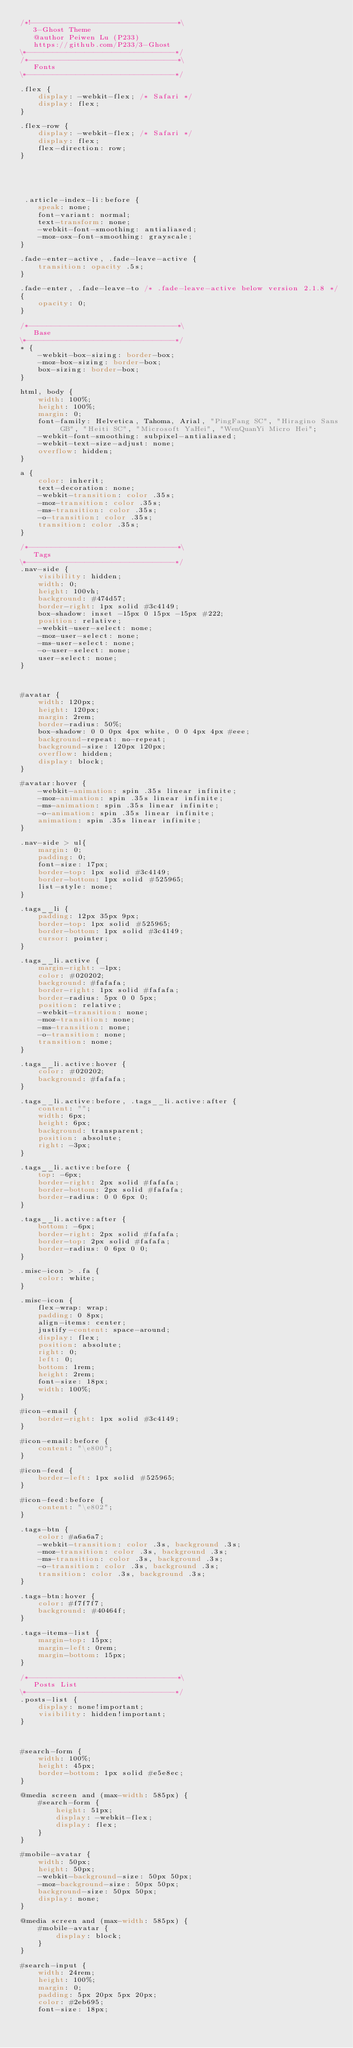Convert code to text. <code><loc_0><loc_0><loc_500><loc_500><_CSS_>/*!--------------------------------*\
   3-Ghost Theme
   @author Peiwen Lu (P233)
   https://github.com/P233/3-Ghost
\*---------------------------------*/
/*---------------------------------*\
   Fonts
\*---------------------------------*/

.flex {
    display: -webkit-flex; /* Safari */
    display: flex;
}

.flex-row {
    display: -webkit-flex; /* Safari */
    display: flex;
    flex-direction: row;
}





 .article-index-li:before {
    speak: none;
    font-variant: normal;
    text-transform: none;
    -webkit-font-smoothing: antialiased;
    -moz-osx-font-smoothing: grayscale;
}

.fade-enter-active, .fade-leave-active {
    transition: opacity .5s;
}

.fade-enter, .fade-leave-to /* .fade-leave-active below version 2.1.8 */
{
    opacity: 0;
}

/*---------------------------------*\
   Base
\*---------------------------------*/
* {
    -webkit-box-sizing: border-box;
    -moz-box-sizing: border-box;
    box-sizing: border-box;
}

html, body {
    width: 100%;
    height: 100%;
    margin: 0;
    font-family: Helvetica, Tahoma, Arial, "PingFang SC", "Hiragino Sans GB", "Heiti SC", "Microsoft YaHei", "WenQuanYi Micro Hei";
    -webkit-font-smoothing: subpixel-antialiased;
    -webkit-text-size-adjust: none;
    overflow: hidden;
}

a {
    color: inherit;
    text-decoration: none;
    -webkit-transition: color .35s;
    -moz-transition: color .35s;
    -ms-transition: color .35s;
    -o-transition: color .35s;
    transition: color .35s;
}

/*---------------------------------*\
   Tags
\*---------------------------------*/
.nav-side {
    visibility: hidden;
    width: 0;
    height: 100vh;
    background: #474d57;
    border-right: 1px solid #3c4149;
    box-shadow: inset -15px 0 15px -15px #222;
    position: relative;
    -webkit-user-select: none;
    -moz-user-select: none;
    -ms-user-select: none;
    -o-user-select: none;
    user-select: none;
}



#avatar {
    width: 120px;
    height: 120px;
    margin: 2rem;
    border-radius: 50%;
    box-shadow: 0 0 0px 4px white, 0 0 4px 4px #eee;
    background-repeat: no-repeat;
    background-size: 120px 120px;
    overflow: hidden;
    display: block;
}

#avatar:hover {
    -webkit-animation: spin .35s linear infinite;
    -moz-animation: spin .35s linear infinite;
    -ms-animation: spin .35s linear infinite;
    -o-animation: spin .35s linear infinite;
    animation: spin .35s linear infinite;
}

.nav-side > ul{
    margin: 0;
    padding: 0;
    font-size: 17px;
    border-top: 1px solid #3c4149;
    border-bottom: 1px solid #525965;
    list-style: none;
}

.tags__li {
    padding: 12px 35px 9px;
    border-top: 1px solid #525965;
    border-bottom: 1px solid #3c4149;
    cursor: pointer;
}

.tags__li.active {
    margin-right: -1px;
    color: #020202;
    background: #fafafa;
    border-right: 1px solid #fafafa;
    border-radius: 5px 0 0 5px;
    position: relative;
    -webkit-transition: none;
    -moz-transition: none;
    -ms-transition: none;
    -o-transition: none;
    transition: none;
}

.tags__li.active:hover {
    color: #020202;
    background: #fafafa;
}

.tags__li.active:before, .tags__li.active:after {
    content: "";
    width: 6px;
    height: 6px;
    background: transparent;
    position: absolute;
    right: -3px;
}

.tags__li.active:before {
    top: -6px;
    border-right: 2px solid #fafafa;
    border-bottom: 2px solid #fafafa;
    border-radius: 0 0 6px 0;
}

.tags__li.active:after {
    bottom: -6px;
    border-right: 2px solid #fafafa;
    border-top: 2px solid #fafafa;
    border-radius: 0 6px 0 0;
}

.misc-icon > .fa {
    color: white;
}

.misc-icon {
    flex-wrap: wrap;
    padding: 0 8px;
    align-items: center;
    justify-content: space-around;
    display: flex;
    position: absolute;
    right: 0;
    left: 0;
    bottom: 1rem;
    height: 2rem;
    font-size: 18px;
    width: 100%;
}

#icon-email {
    border-right: 1px solid #3c4149;
}

#icon-email:before {
    content: "\e800";
}

#icon-feed {
    border-left: 1px solid #525965;
}

#icon-feed:before {
    content: "\e802";
}

.tags-btn {
    color: #a6a6a7;
    -webkit-transition: color .3s, background .3s;
    -moz-transition: color .3s, background .3s;
    -ms-transition: color .3s, background .3s;
    -o-transition: color .3s, background .3s;
    transition: color .3s, background .3s;
}

.tags-btn:hover {
    color: #f7f7f7;
    background: #40464f;
}

.tags-items-list {
    margin-top: 15px;
    margin-left: 0rem;
    margin-bottom: 15px;
}

/*---------------------------------*\
   Posts List
\*---------------------------------*/
.posts-list {
    display: none!important;
    visibility: hidden!important;
}



#search-form {
    width: 100%;
    height: 45px;
    border-bottom: 1px solid #e5e8ec;
}

@media screen and (max-width: 585px) {
    #search-form {
        height: 51px;
        display: -webkit-flex;
        display: flex;
    }
}

#mobile-avatar {
    width: 50px;
    height: 50px;
    -webkit-background-size: 50px 50px;
    -moz-background-size: 50px 50px;
    background-size: 50px 50px;
    display: none;
}

@media screen and (max-width: 585px) {
    #mobile-avatar {
        display: block;
    }
}

#search-input {
    width: 24rem;
    height: 100%;
    margin: 0;
    padding: 5px 20px 5px 20px;
    color: #2eb695;
    font-size: 18px;</code> 